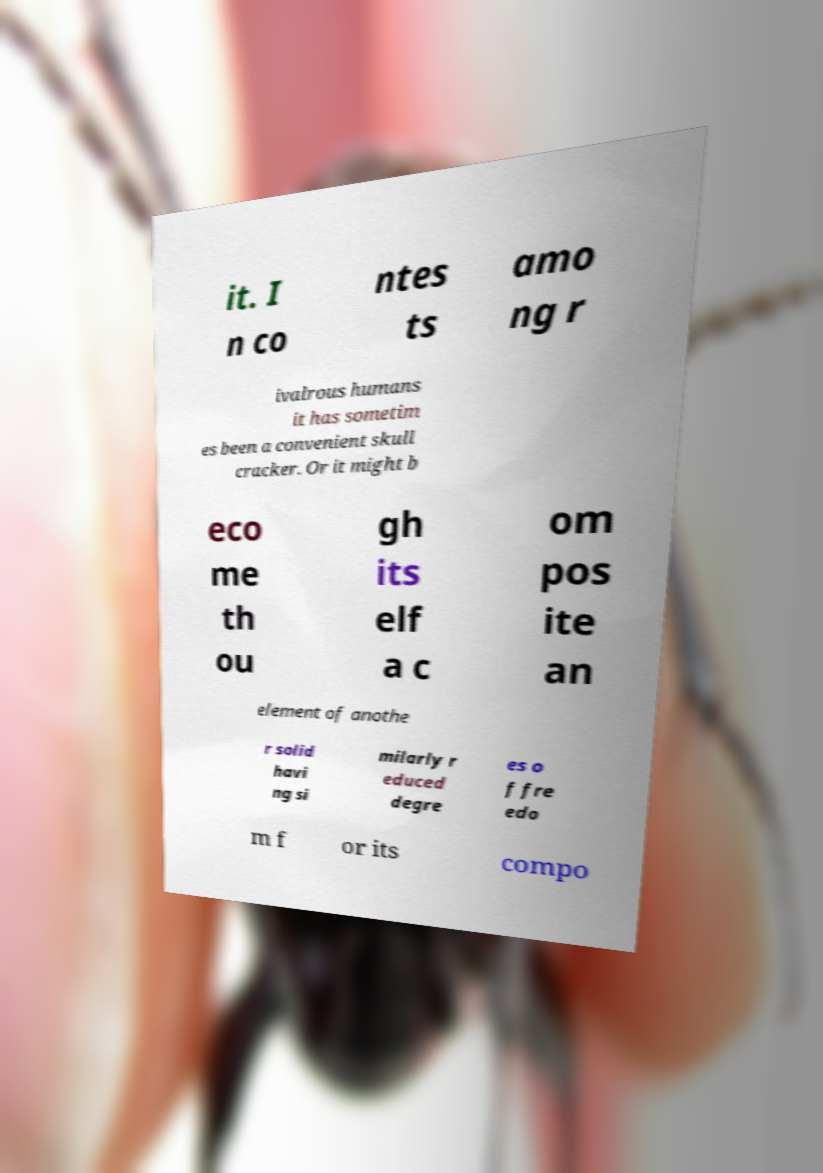Please read and relay the text visible in this image. What does it say? it. I n co ntes ts amo ng r ivalrous humans it has sometim es been a convenient skull cracker. Or it might b eco me th ou gh its elf a c om pos ite an element of anothe r solid havi ng si milarly r educed degre es o f fre edo m f or its compo 